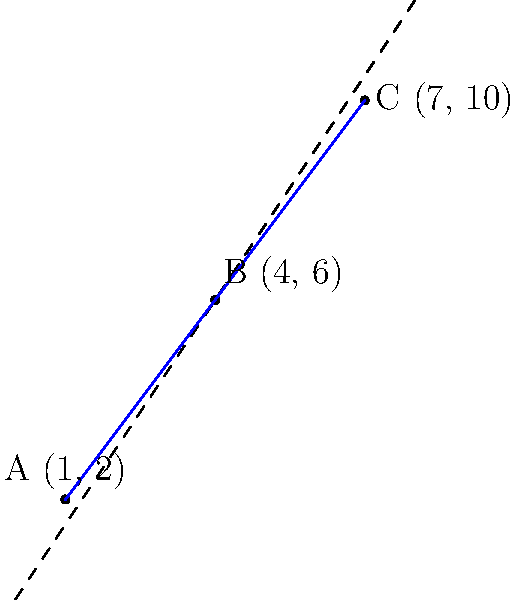At a crime scene, three evidence markers are placed at the following coordinates: A(1, 2), B(4, 6), and C(7, 10). Using the distance formula, determine if these three markers are collinear. Show your work and explain your conclusion. To determine if three points are collinear, we can use the distance formula to check if the distance between the furthest two points is equal to the sum of the distances between the other two pairs of points.

Step 1: Calculate the distances between each pair of points using the distance formula:
$d = \sqrt{(x_2-x_1)^2 + (y_2-y_1)^2}$

AB: $d_{AB} = \sqrt{(4-1)^2 + (6-2)^2} = \sqrt{3^2 + 4^2} = \sqrt{25} = 5$
BC: $d_{BC} = \sqrt{(7-4)^2 + (10-6)^2} = \sqrt{3^2 + 4^2} = \sqrt{25} = 5$
AC: $d_{AC} = \sqrt{(7-1)^2 + (10-2)^2} = \sqrt{6^2 + 8^2} = \sqrt{100} = 10$

Step 2: Check if the distance AC is equal to the sum of AB and BC.

$d_{AC} = d_{AB} + d_{BC}$
$10 = 5 + 5$
$10 = 10$

Step 3: Interpret the results.
Since the distance AC is equal to the sum of AB and BC, we can conclude that the three points are collinear.

This method works because if three points are collinear, they form a straight line. In a straight line, the distance between the two end points is always equal to the sum of the distances between the intermediate points.
Answer: The three evidence markers are collinear. 